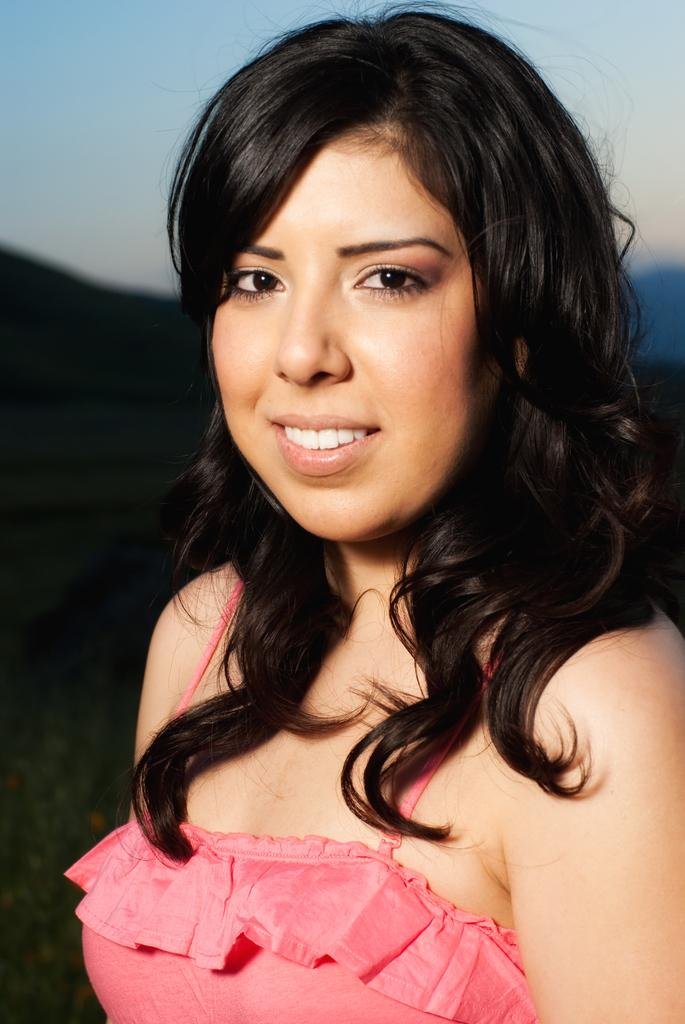What is the main subject of the image? There is a woman in the image. What is the woman wearing? The woman is wearing a pink dress. What is the woman's facial expression? The woman is smiling. Can you describe the background of the image? The background of the image is blurred. How many fingers is the woman holding up in the image? There is no indication of the woman holding up any fingers in the image. 